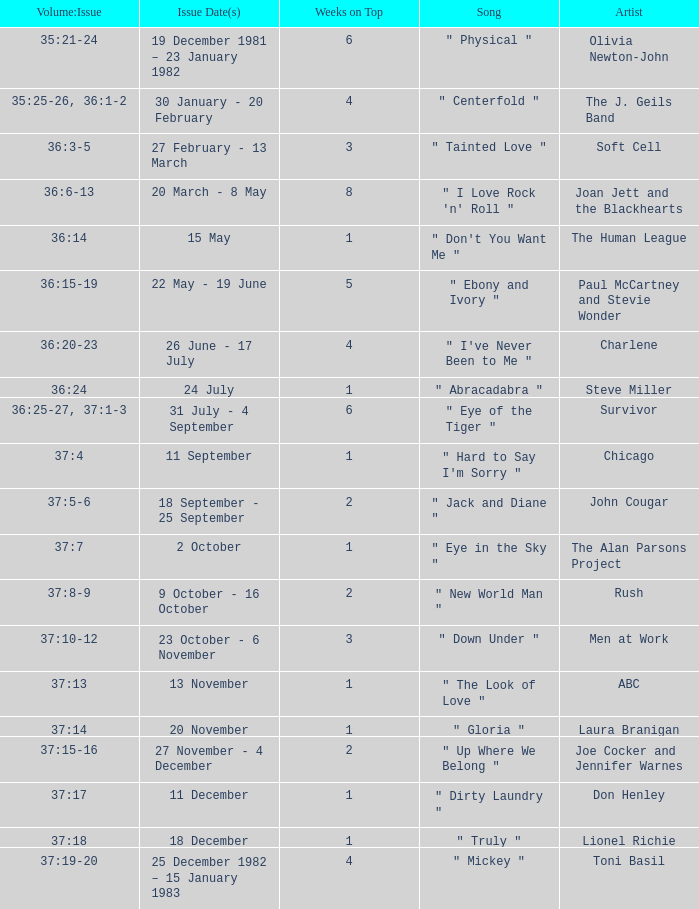Which Issue Date(s) has Weeks on Top larger than 3, and a Volume: Issue of 35:25-26, 36:1-2? 30 January - 20 February. 